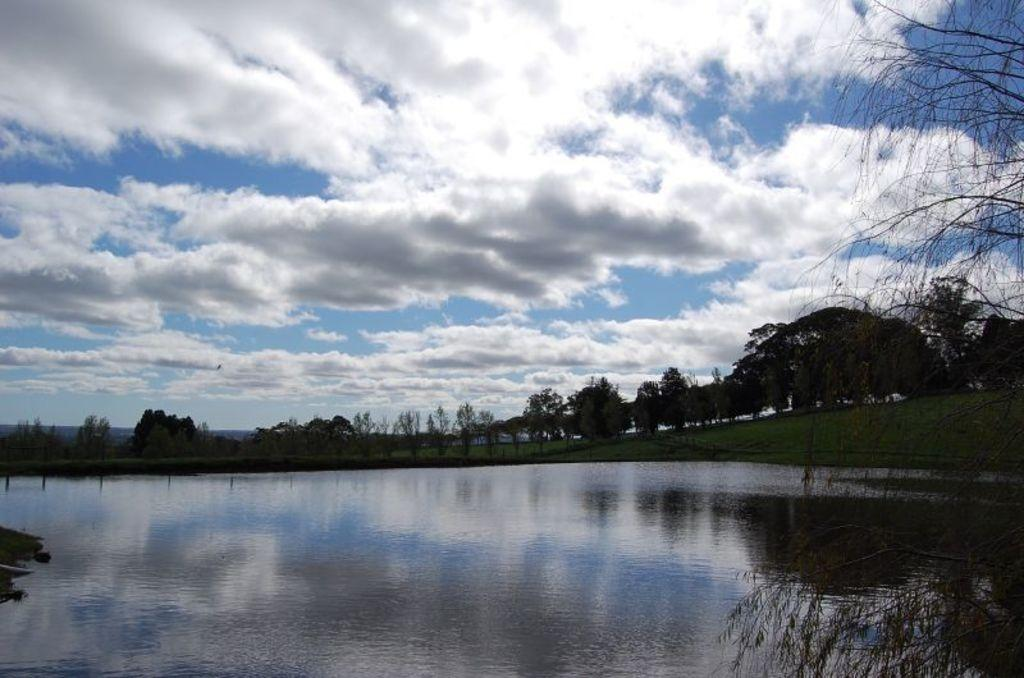What is present in the front of the image? There is water in the front of the image. What can be seen in the background of the image? There are trees in the background of the image. What type of vegetation is on the ground in the image? There is grass on the ground in the image. How would you describe the sky in the image? The sky is cloudy in the image. How many pears can be seen on the toes of the deer in the image? There are no pears, toes, or deer present in the image. 